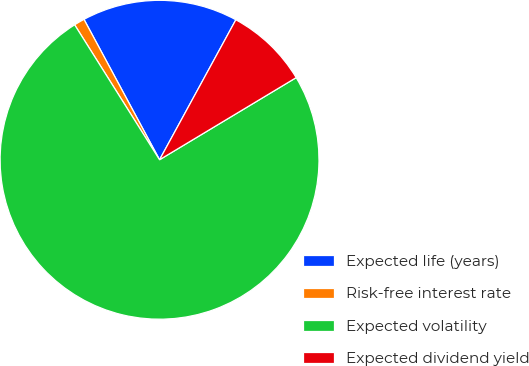Convert chart to OTSL. <chart><loc_0><loc_0><loc_500><loc_500><pie_chart><fcel>Expected life (years)<fcel>Risk-free interest rate<fcel>Expected volatility<fcel>Expected dividend yield<nl><fcel>15.8%<fcel>1.08%<fcel>74.67%<fcel>8.44%<nl></chart> 